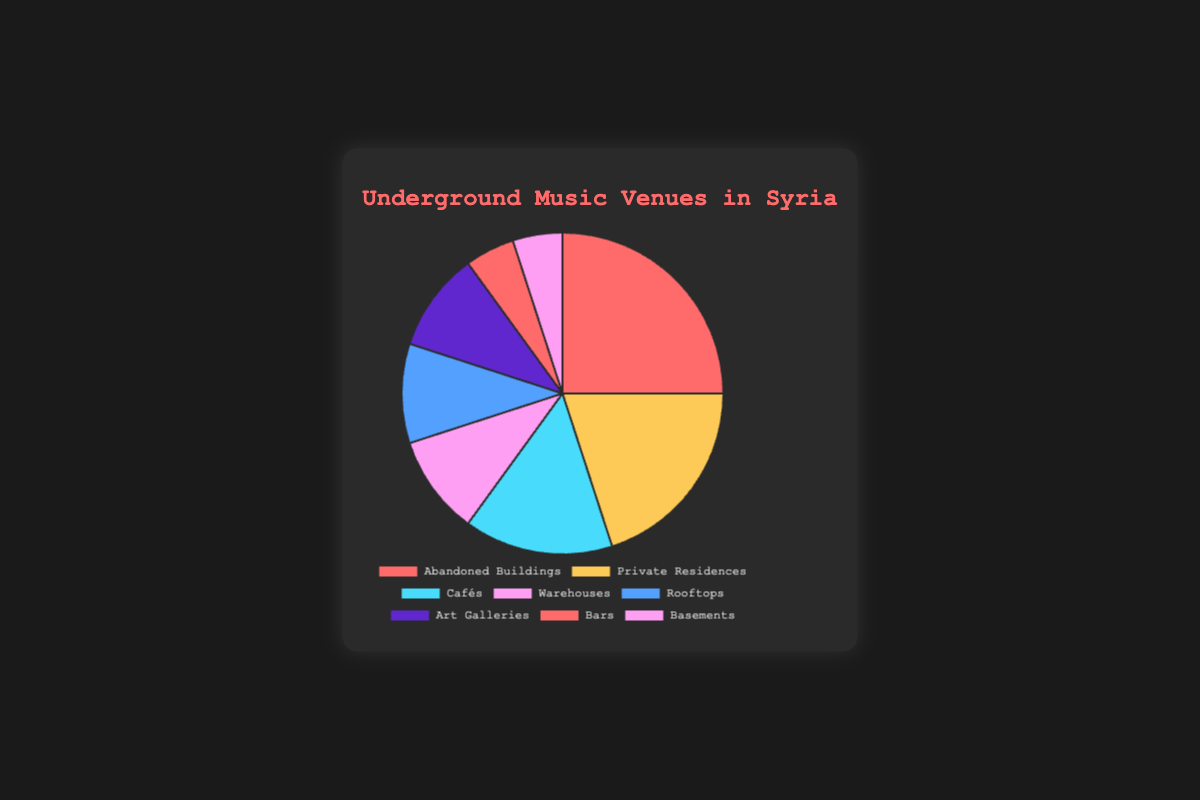Which type of venue is used most frequently for underground music events in Syria? Looking at the pie chart, "Abandoned Buildings" has the largest slice, which represents 25%.
Answer: Abandoned Buildings What are the two least commonly used venues for underground music events? The smallest slices in the pie chart represent "Bars" and "Basements," each with 5%.
Answer: Bars and Basements What percentage of underground music events take place in either Warehouses or Rooftops? Combine the percentages of Warehouses (10%) and Rooftops (10%) from the pie chart to get 10% + 10% = 20%.
Answer: 20% How does the frequency of events at Private Residences compare to those at Cafés? Private Residences have a slice representing 20%, while Cafés have a smaller slice representing 15%.
Answer: Private Residences (20%) > Cafés (15%) Which venues have equal representation in terms of percentage? Warehouses, Rooftops, and Art Galleries each have slices representing 10% of the pie chart.
Answer: Warehouses, Rooftops, and Art Galleries What is the combined percentage of events held in Art Galleries, Bars, and Basements? Add the percentages from Art Galleries (10%), Bars (5%), and Basements (5%): 10% + 5% + 5% = 20%.
Answer: 20% Which venues have the same visual representation in color? The pie chart uses the same color for the slices representing Abandoned Buildings and Bars, which are both shown in red.
Answer: Abandoned Buildings and Bars How much larger is the percentage of events in Abandoned Buildings compared to those in Warehouses? Subtract the percentage of Warehouses (10%) from that of Abandoned Buildings (25%): 25% - 10% = 15%.
Answer: 15% If you were to combine the percentages of events held at Abandoned Buildings and Private Residences, what would be the total? Add the percentages of Abandoned Buildings (25%) and Private Residences (20%): 25% + 20% = 45%.
Answer: 45% Which venue type is represented in blue on the pie chart? The blue slice of the pie chart corresponds to "Rooftops," which represents 10%.
Answer: Rooftops 